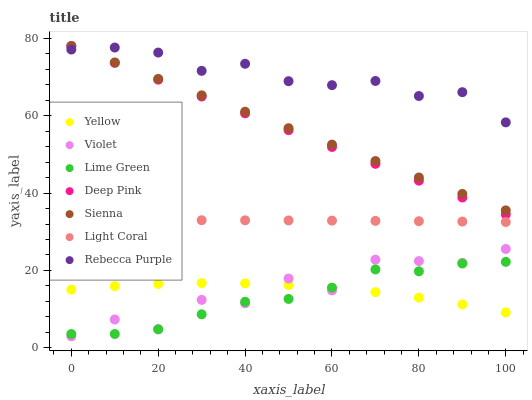Does Lime Green have the minimum area under the curve?
Answer yes or no. Yes. Does Rebecca Purple have the maximum area under the curve?
Answer yes or no. Yes. Does Deep Pink have the minimum area under the curve?
Answer yes or no. No. Does Deep Pink have the maximum area under the curve?
Answer yes or no. No. Is Deep Pink the smoothest?
Answer yes or no. Yes. Is Violet the roughest?
Answer yes or no. Yes. Is Yellow the smoothest?
Answer yes or no. No. Is Yellow the roughest?
Answer yes or no. No. Does Violet have the lowest value?
Answer yes or no. Yes. Does Deep Pink have the lowest value?
Answer yes or no. No. Does Sienna have the highest value?
Answer yes or no. Yes. Does Yellow have the highest value?
Answer yes or no. No. Is Yellow less than Sienna?
Answer yes or no. Yes. Is Sienna greater than Yellow?
Answer yes or no. Yes. Does Yellow intersect Lime Green?
Answer yes or no. Yes. Is Yellow less than Lime Green?
Answer yes or no. No. Is Yellow greater than Lime Green?
Answer yes or no. No. Does Yellow intersect Sienna?
Answer yes or no. No. 